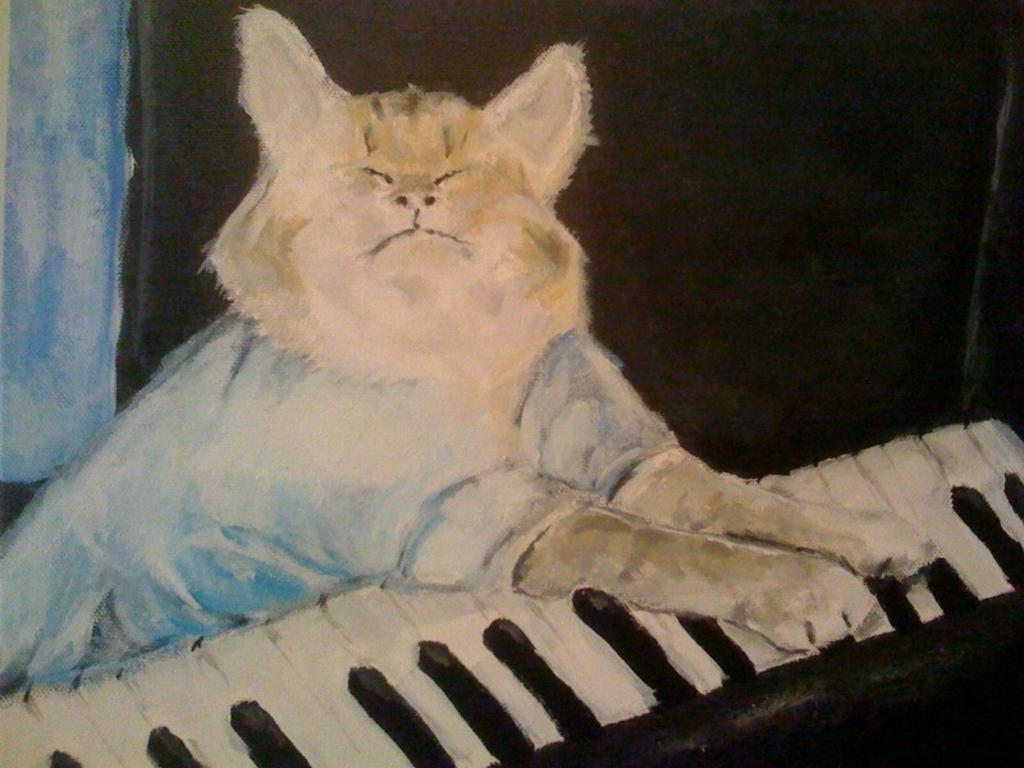What type of artwork is shown in the image? The image is a painting. What subject is depicted in the painting? The painting depicts a cat. What activity is the cat engaged in? The cat is playing a keyboard. What color is the background of the painting? The background of the painting is black. What type of magic is the cat performing with the pin and fork in the image? There is no pin, fork, or magic present in the image; it depicts a cat playing a keyboard against a black background. 